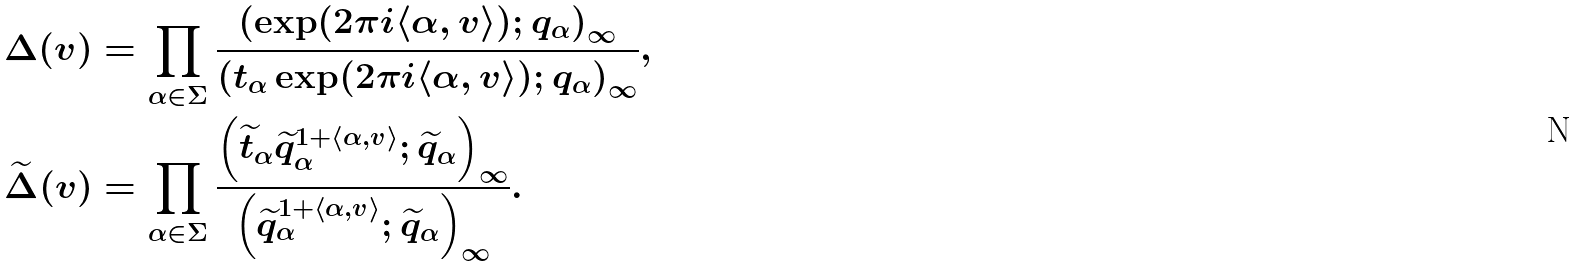Convert formula to latex. <formula><loc_0><loc_0><loc_500><loc_500>\Delta ( v ) & = \prod _ { \alpha \in \Sigma } \frac { \left ( \exp ( 2 \pi i \langle \alpha , v \rangle ) ; q _ { \alpha } \right ) _ { \infty } } { \left ( t _ { \alpha } \exp ( 2 \pi i \langle \alpha , v \rangle ) ; q _ { \alpha } \right ) _ { \infty } } , \\ \widetilde { \Delta } ( v ) & = \prod _ { \alpha \in \Sigma } \frac { \left ( \widetilde { t } _ { \alpha } \widetilde { q } _ { \alpha } ^ { 1 + \langle \alpha , v \rangle } ; \widetilde { q } _ { \alpha } \right ) _ { \infty } } { \left ( \widetilde { q } _ { \alpha } ^ { 1 + \langle \alpha , v \rangle } ; \widetilde { q } _ { \alpha } \right ) _ { \infty } } .</formula> 